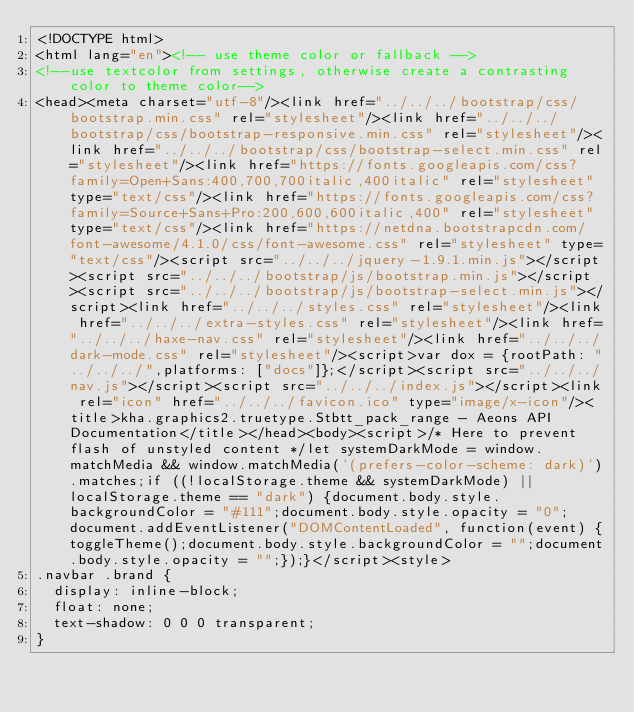Convert code to text. <code><loc_0><loc_0><loc_500><loc_500><_HTML_><!DOCTYPE html>
<html lang="en"><!-- use theme color or fallback -->
<!--use textcolor from settings, otherwise create a contrasting color to theme color-->
<head><meta charset="utf-8"/><link href="../../../bootstrap/css/bootstrap.min.css" rel="stylesheet"/><link href="../../../bootstrap/css/bootstrap-responsive.min.css" rel="stylesheet"/><link href="../../../bootstrap/css/bootstrap-select.min.css" rel="stylesheet"/><link href="https://fonts.googleapis.com/css?family=Open+Sans:400,700,700italic,400italic" rel="stylesheet" type="text/css"/><link href="https://fonts.googleapis.com/css?family=Source+Sans+Pro:200,600,600italic,400" rel="stylesheet" type="text/css"/><link href="https://netdna.bootstrapcdn.com/font-awesome/4.1.0/css/font-awesome.css" rel="stylesheet" type="text/css"/><script src="../../../jquery-1.9.1.min.js"></script><script src="../../../bootstrap/js/bootstrap.min.js"></script><script src="../../../bootstrap/js/bootstrap-select.min.js"></script><link href="../../../styles.css" rel="stylesheet"/><link href="../../../extra-styles.css" rel="stylesheet"/><link href="../../../haxe-nav.css" rel="stylesheet"/><link href="../../../dark-mode.css" rel="stylesheet"/><script>var dox = {rootPath: "../../../",platforms: ["docs"]};</script><script src="../../../nav.js"></script><script src="../../../index.js"></script><link rel="icon" href="../../../favicon.ico" type="image/x-icon"/><title>kha.graphics2.truetype.Stbtt_pack_range - Aeons API Documentation</title></head><body><script>/* Here to prevent flash of unstyled content */let systemDarkMode = window.matchMedia && window.matchMedia('(prefers-color-scheme: dark)').matches;if ((!localStorage.theme && systemDarkMode) || localStorage.theme == "dark") {document.body.style.backgroundColor = "#111";document.body.style.opacity = "0";document.addEventListener("DOMContentLoaded", function(event) {toggleTheme();document.body.style.backgroundColor = "";document.body.style.opacity = "";});}</script><style>
.navbar .brand {
	display: inline-block;
	float: none;
	text-shadow: 0 0 0 transparent;
}</code> 